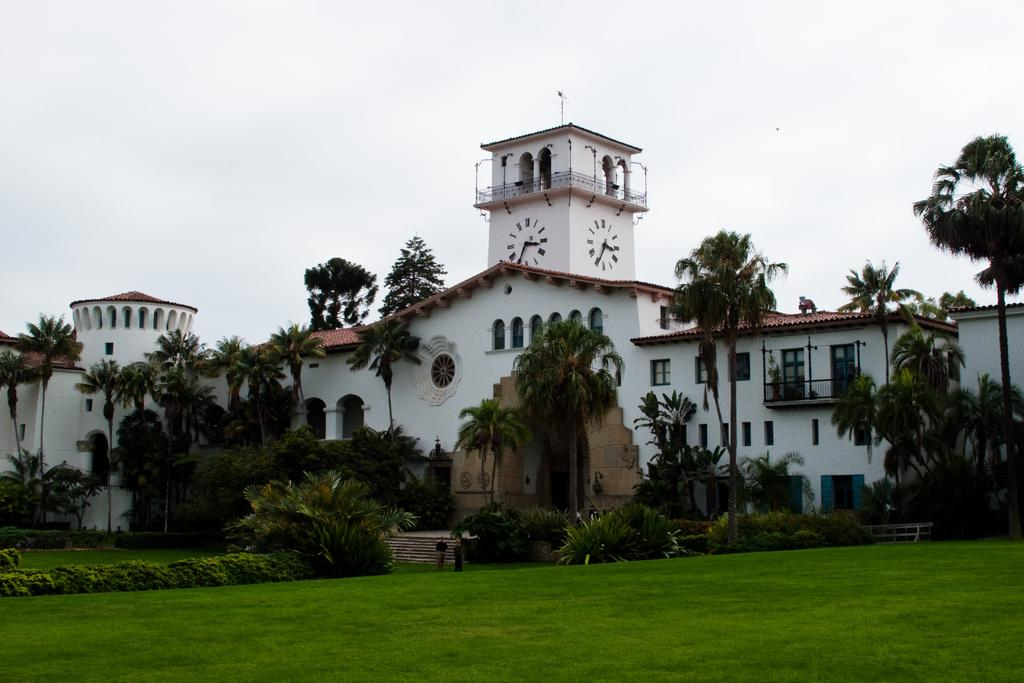How many people are in the image? There are two people in the image. Where are the people located? The people are on the grass. What other natural elements can be seen in the image? There are trees in the image. Are there any architectural features present? Yes, there are steps in the image. What type of structures can be seen in the background? There are buildings with windows in the image. What is visible in the background of the image? The sky is visible in the background of the image. What type of cake is being served at the airport in the image? There is no cake or airport present in the image; it features two people on the grass with trees and buildings in the background. What is the noise level in the image? The noise level cannot be determined from the image, as it is a still photograph and does not capture sound. 